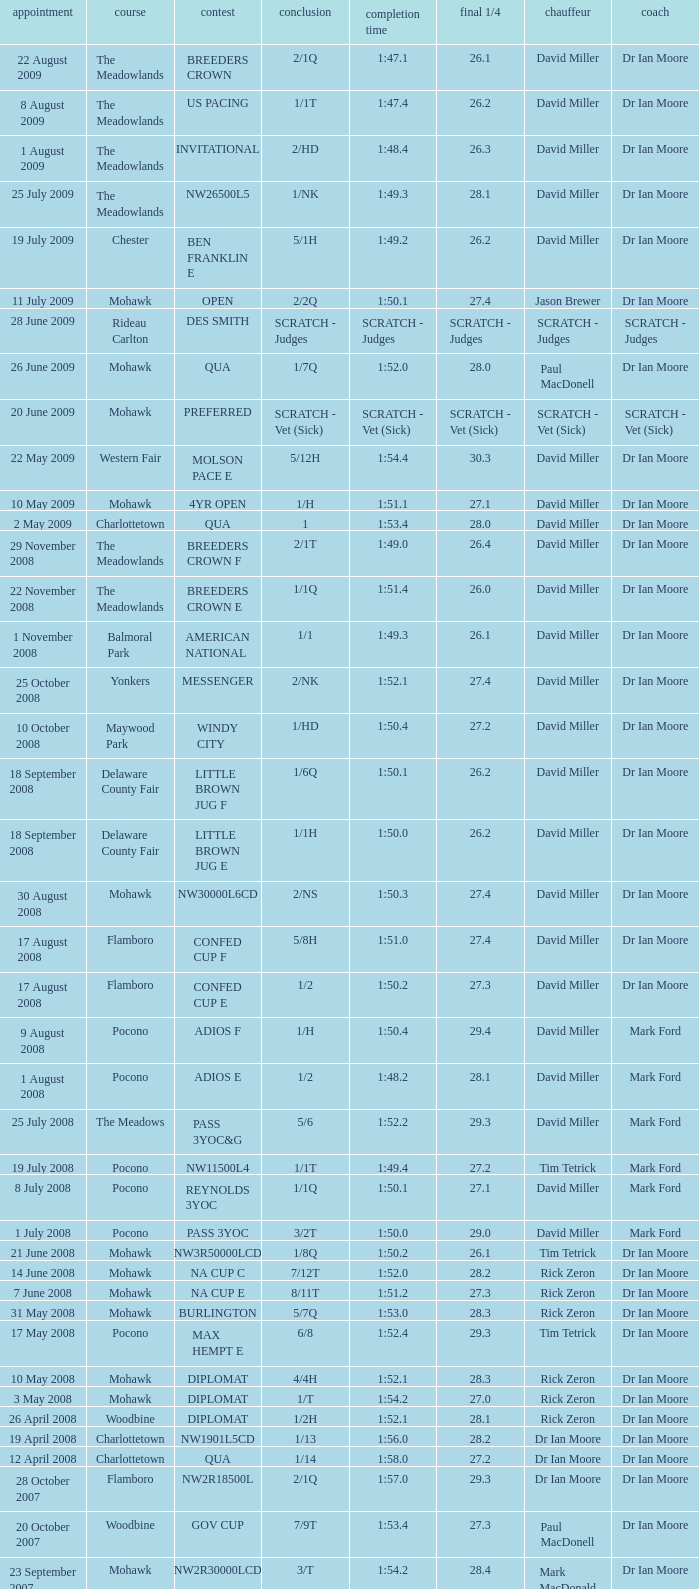What is the finishing time with a 2/1q finish on the Meadowlands track? 1:47.1. 